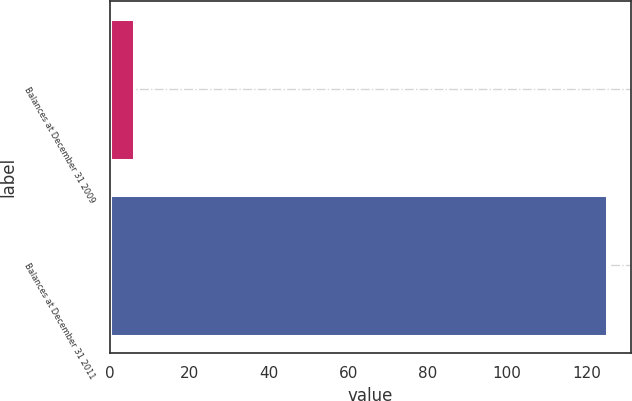<chart> <loc_0><loc_0><loc_500><loc_500><bar_chart><fcel>Balances at December 31 2009<fcel>Balances at December 31 2011<nl><fcel>6<fcel>125<nl></chart> 